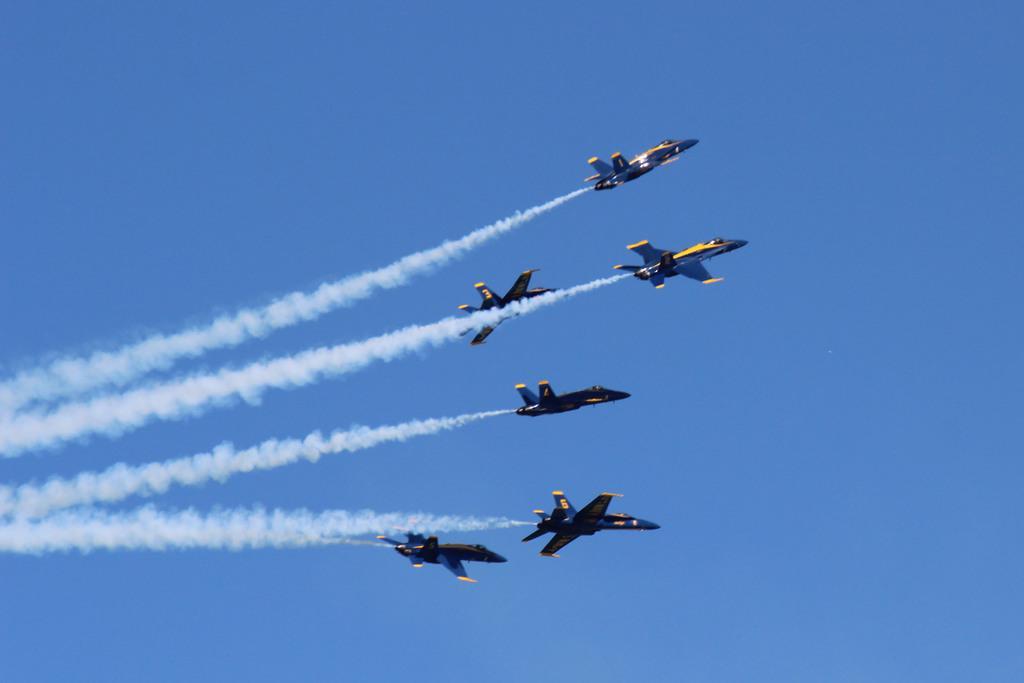In one or two sentences, can you explain what this image depicts? In this image there are six jets flying in the sky leaving smoke trails. 